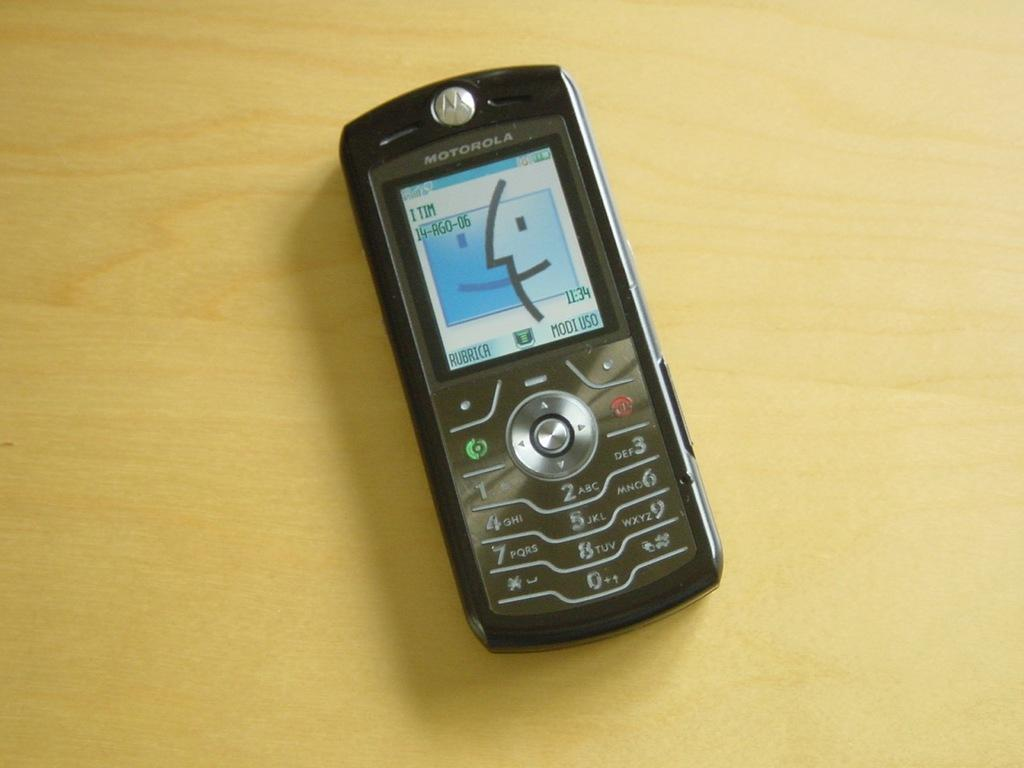What is the color of the mobile phone in the image? The mobile phone in the image is black. What is the color of the table on which the mobile phone is placed? The table is yellow. What brand is the mobile phone in the image? The word "MOTOROLA" is written on top of the mobile phone, indicating that it is a Motorola device. Can you see any waves in the image? There are no waves present in the image; it features a black mobile phone placed on a yellow table. Is there a banana on the table next to the mobile phone? There is no banana visible in the image; only the black mobile phone and the yellow table are present. 